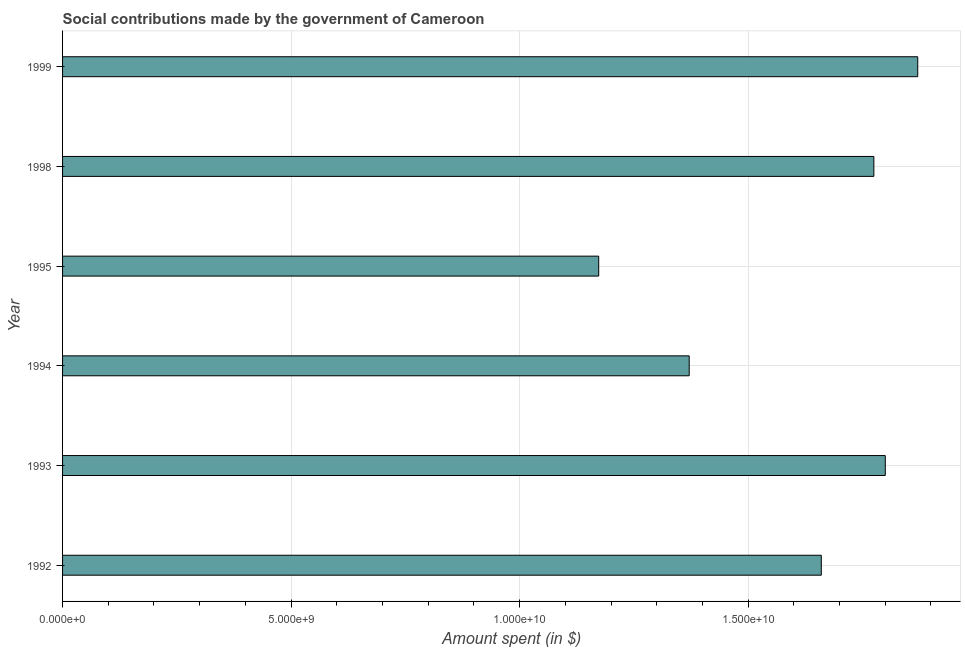Does the graph contain any zero values?
Give a very brief answer. No. Does the graph contain grids?
Provide a succinct answer. Yes. What is the title of the graph?
Your answer should be very brief. Social contributions made by the government of Cameroon. What is the label or title of the X-axis?
Provide a succinct answer. Amount spent (in $). What is the label or title of the Y-axis?
Give a very brief answer. Year. What is the amount spent in making social contributions in 1995?
Keep it short and to the point. 1.17e+1. Across all years, what is the maximum amount spent in making social contributions?
Your answer should be compact. 1.87e+1. Across all years, what is the minimum amount spent in making social contributions?
Your answer should be compact. 1.17e+1. In which year was the amount spent in making social contributions maximum?
Offer a very short reply. 1999. What is the sum of the amount spent in making social contributions?
Your answer should be compact. 9.65e+1. What is the difference between the amount spent in making social contributions in 1992 and 1993?
Keep it short and to the point. -1.40e+09. What is the average amount spent in making social contributions per year?
Give a very brief answer. 1.61e+1. What is the median amount spent in making social contributions?
Give a very brief answer. 1.72e+1. What is the ratio of the amount spent in making social contributions in 1992 to that in 1999?
Keep it short and to the point. 0.89. What is the difference between the highest and the second highest amount spent in making social contributions?
Keep it short and to the point. 7.10e+08. Is the sum of the amount spent in making social contributions in 1992 and 1995 greater than the maximum amount spent in making social contributions across all years?
Give a very brief answer. Yes. What is the difference between the highest and the lowest amount spent in making social contributions?
Offer a very short reply. 6.98e+09. How many bars are there?
Offer a terse response. 6. How many years are there in the graph?
Your answer should be compact. 6. What is the difference between two consecutive major ticks on the X-axis?
Your response must be concise. 5.00e+09. What is the Amount spent (in $) in 1992?
Offer a very short reply. 1.66e+1. What is the Amount spent (in $) in 1993?
Provide a succinct answer. 1.80e+1. What is the Amount spent (in $) of 1994?
Your response must be concise. 1.37e+1. What is the Amount spent (in $) in 1995?
Make the answer very short. 1.17e+1. What is the Amount spent (in $) in 1998?
Offer a very short reply. 1.78e+1. What is the Amount spent (in $) in 1999?
Provide a short and direct response. 1.87e+1. What is the difference between the Amount spent (in $) in 1992 and 1993?
Your response must be concise. -1.40e+09. What is the difference between the Amount spent (in $) in 1992 and 1994?
Keep it short and to the point. 2.89e+09. What is the difference between the Amount spent (in $) in 1992 and 1995?
Offer a terse response. 4.87e+09. What is the difference between the Amount spent (in $) in 1992 and 1998?
Your answer should be very brief. -1.15e+09. What is the difference between the Amount spent (in $) in 1992 and 1999?
Keep it short and to the point. -2.11e+09. What is the difference between the Amount spent (in $) in 1993 and 1994?
Ensure brevity in your answer.  4.29e+09. What is the difference between the Amount spent (in $) in 1993 and 1995?
Keep it short and to the point. 6.27e+09. What is the difference between the Amount spent (in $) in 1993 and 1998?
Your answer should be compact. 2.50e+08. What is the difference between the Amount spent (in $) in 1993 and 1999?
Provide a succinct answer. -7.10e+08. What is the difference between the Amount spent (in $) in 1994 and 1995?
Your answer should be very brief. 1.98e+09. What is the difference between the Amount spent (in $) in 1994 and 1998?
Provide a short and direct response. -4.04e+09. What is the difference between the Amount spent (in $) in 1994 and 1999?
Give a very brief answer. -5.00e+09. What is the difference between the Amount spent (in $) in 1995 and 1998?
Keep it short and to the point. -6.02e+09. What is the difference between the Amount spent (in $) in 1995 and 1999?
Offer a terse response. -6.98e+09. What is the difference between the Amount spent (in $) in 1998 and 1999?
Provide a succinct answer. -9.60e+08. What is the ratio of the Amount spent (in $) in 1992 to that in 1993?
Offer a very short reply. 0.92. What is the ratio of the Amount spent (in $) in 1992 to that in 1994?
Ensure brevity in your answer.  1.21. What is the ratio of the Amount spent (in $) in 1992 to that in 1995?
Keep it short and to the point. 1.42. What is the ratio of the Amount spent (in $) in 1992 to that in 1998?
Keep it short and to the point. 0.94. What is the ratio of the Amount spent (in $) in 1992 to that in 1999?
Your answer should be compact. 0.89. What is the ratio of the Amount spent (in $) in 1993 to that in 1994?
Make the answer very short. 1.31. What is the ratio of the Amount spent (in $) in 1993 to that in 1995?
Offer a terse response. 1.53. What is the ratio of the Amount spent (in $) in 1993 to that in 1998?
Your response must be concise. 1.01. What is the ratio of the Amount spent (in $) in 1994 to that in 1995?
Your answer should be very brief. 1.17. What is the ratio of the Amount spent (in $) in 1994 to that in 1998?
Ensure brevity in your answer.  0.77. What is the ratio of the Amount spent (in $) in 1994 to that in 1999?
Your response must be concise. 0.73. What is the ratio of the Amount spent (in $) in 1995 to that in 1998?
Give a very brief answer. 0.66. What is the ratio of the Amount spent (in $) in 1995 to that in 1999?
Give a very brief answer. 0.63. What is the ratio of the Amount spent (in $) in 1998 to that in 1999?
Offer a very short reply. 0.95. 